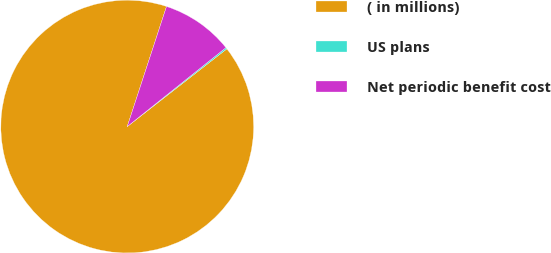<chart> <loc_0><loc_0><loc_500><loc_500><pie_chart><fcel>( in millions)<fcel>US plans<fcel>Net periodic benefit cost<nl><fcel>90.57%<fcel>0.19%<fcel>9.23%<nl></chart> 